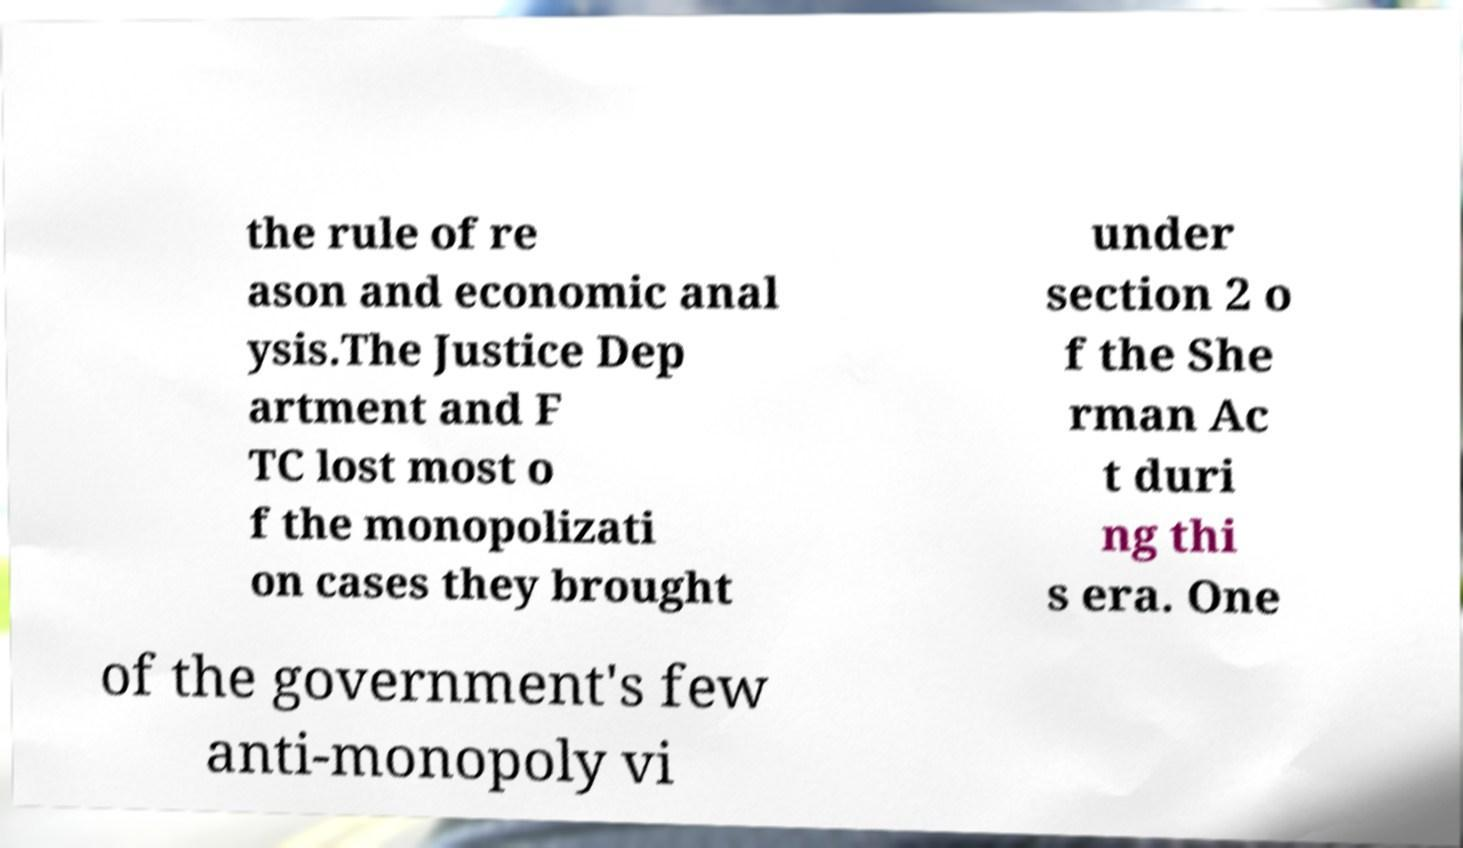For documentation purposes, I need the text within this image transcribed. Could you provide that? the rule of re ason and economic anal ysis.The Justice Dep artment and F TC lost most o f the monopolizati on cases they brought under section 2 o f the She rman Ac t duri ng thi s era. One of the government's few anti-monopoly vi 